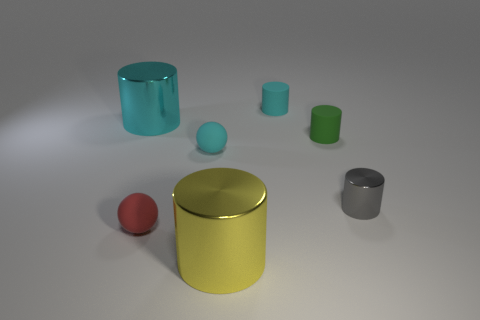Subtract 1 cylinders. How many cylinders are left? 4 Subtract all gray cylinders. How many cylinders are left? 4 Subtract all yellow cylinders. How many cylinders are left? 4 Add 2 red rubber balls. How many objects exist? 9 Subtract all purple cylinders. Subtract all blue spheres. How many cylinders are left? 5 Subtract all cylinders. How many objects are left? 2 Subtract all large cyan shiny cubes. Subtract all green rubber cylinders. How many objects are left? 6 Add 2 small red balls. How many small red balls are left? 3 Add 3 small cyan cylinders. How many small cyan cylinders exist? 4 Subtract 0 brown cylinders. How many objects are left? 7 